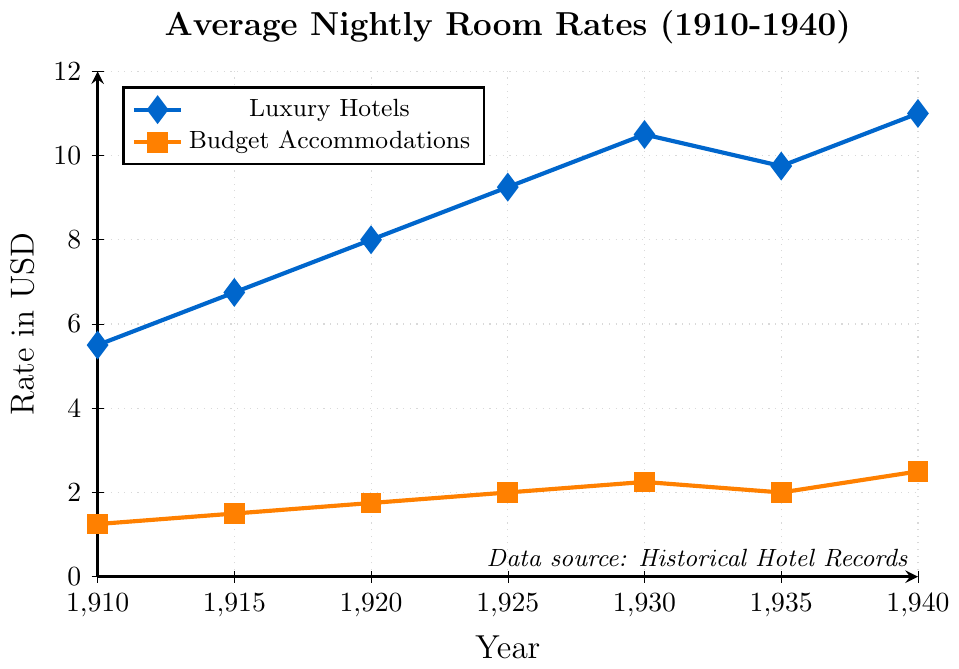Which year had the highest average nightly room rate for luxury hotels? By looking at the plotted points and their respective values for luxury hotels, the highest point is at 1940 with a rate of 11.00 USD.
Answer: 1940 What is the difference in average nightly room rates between luxury hotels and budget accommodations in 1930? The plotted point for luxury hotels in 1930 is 10.50 USD and for budget accommodations, it is 2.25 USD. The difference is 10.50 - 2.25 = 8.25 USD.
Answer: 8.25 USD How did the average nightly room rate for budget accommodations change from 1935 to 1940? In 1935, the rate for budget accommodations was 2.00 USD, and in 1940 it was 2.50 USD. The change is 2.50 - 2.00 = 0.50 USD.
Answer: Increased by 0.50 USD In which year did luxury hotels see a decrease in average nightly room rates compared to the previous recorded year? Observing the plotted points for luxury hotels, there is a decrease from 1930 to 1935 (10.50 USD to 9.75 USD).
Answer: 1935 Which category of hotels (luxury or budget) had a rate of exactly 6.75 USD in any of the given years? By referring to the line plot, the luxury hotels had a rate of 6.75 USD in 1915. Budget accommodations did not reach this value.
Answer: Luxury Hotels What is the average nightly room rate in luxury hotels for the years 1910 and 1920 combined? The rate in 1910 was 5.50 USD and in 1920 it was 8.00 USD. The combined average is (5.50 + 8.00) / 2 = 6.75 USD.
Answer: 6.75 USD How does the 1915 rate for budget accommodations compare visually to its 1940 rate? The value for budget accommodations in 1915 is 1.50 USD, marked with a smaller square compared to 1940, where the rate is 2.50 USD. This shows an upward trend visually.
Answer: 1915 rate is lower than 1940 rate What is the trend in average nightly room rates for luxury hotels from 1910 to 1940? From 1910 to 1930, there is a steady increase; from 1930 to 1935, a decrease; and from 1935 to 1940, an increase. The overall trend is upward.
Answer: Upward trend 